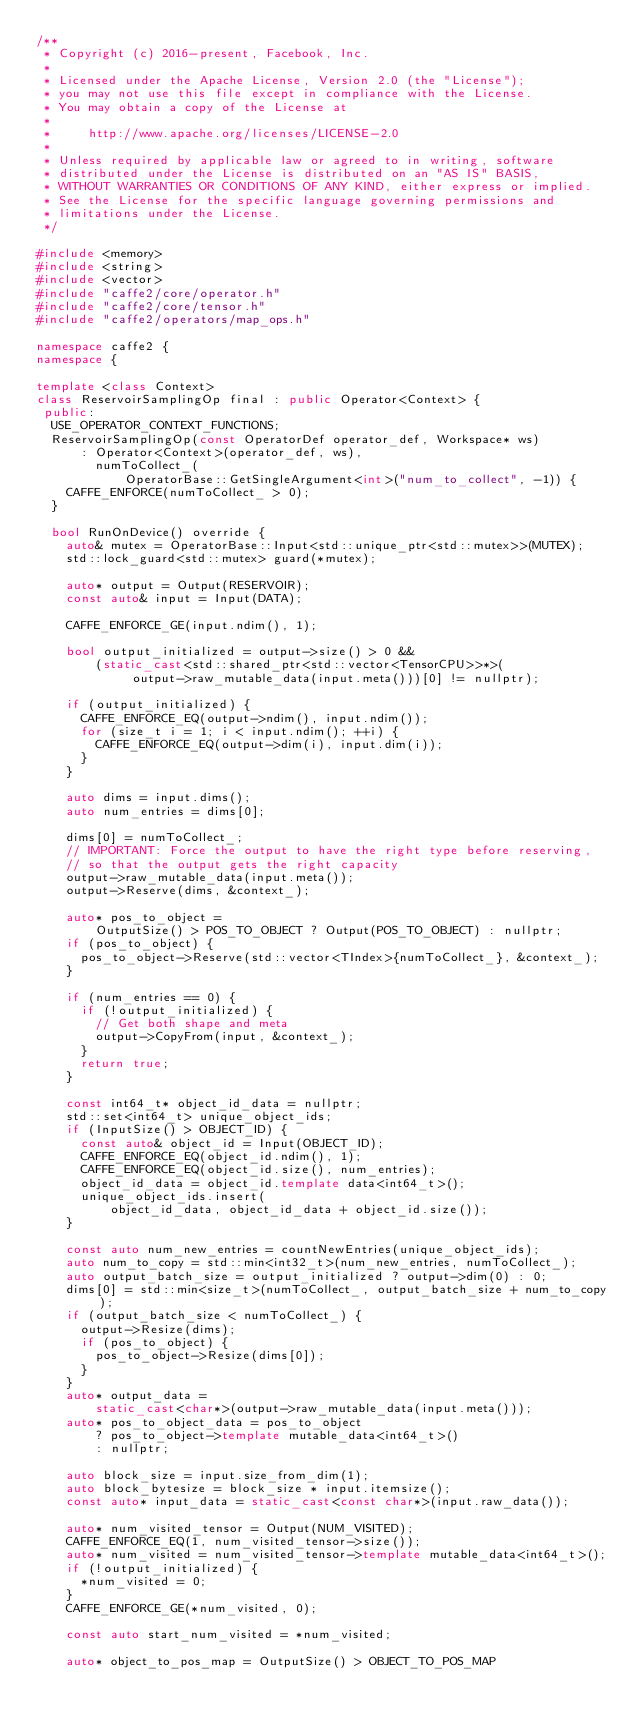<code> <loc_0><loc_0><loc_500><loc_500><_C++_>/**
 * Copyright (c) 2016-present, Facebook, Inc.
 *
 * Licensed under the Apache License, Version 2.0 (the "License");
 * you may not use this file except in compliance with the License.
 * You may obtain a copy of the License at
 *
 *     http://www.apache.org/licenses/LICENSE-2.0
 *
 * Unless required by applicable law or agreed to in writing, software
 * distributed under the License is distributed on an "AS IS" BASIS,
 * WITHOUT WARRANTIES OR CONDITIONS OF ANY KIND, either express or implied.
 * See the License for the specific language governing permissions and
 * limitations under the License.
 */

#include <memory>
#include <string>
#include <vector>
#include "caffe2/core/operator.h"
#include "caffe2/core/tensor.h"
#include "caffe2/operators/map_ops.h"

namespace caffe2 {
namespace {

template <class Context>
class ReservoirSamplingOp final : public Operator<Context> {
 public:
  USE_OPERATOR_CONTEXT_FUNCTIONS;
  ReservoirSamplingOp(const OperatorDef operator_def, Workspace* ws)
      : Operator<Context>(operator_def, ws),
        numToCollect_(
            OperatorBase::GetSingleArgument<int>("num_to_collect", -1)) {
    CAFFE_ENFORCE(numToCollect_ > 0);
  }

  bool RunOnDevice() override {
    auto& mutex = OperatorBase::Input<std::unique_ptr<std::mutex>>(MUTEX);
    std::lock_guard<std::mutex> guard(*mutex);

    auto* output = Output(RESERVOIR);
    const auto& input = Input(DATA);

    CAFFE_ENFORCE_GE(input.ndim(), 1);

    bool output_initialized = output->size() > 0 &&
        (static_cast<std::shared_ptr<std::vector<TensorCPU>>*>(
             output->raw_mutable_data(input.meta()))[0] != nullptr);

    if (output_initialized) {
      CAFFE_ENFORCE_EQ(output->ndim(), input.ndim());
      for (size_t i = 1; i < input.ndim(); ++i) {
        CAFFE_ENFORCE_EQ(output->dim(i), input.dim(i));
      }
    }

    auto dims = input.dims();
    auto num_entries = dims[0];

    dims[0] = numToCollect_;
    // IMPORTANT: Force the output to have the right type before reserving,
    // so that the output gets the right capacity
    output->raw_mutable_data(input.meta());
    output->Reserve(dims, &context_);

    auto* pos_to_object =
        OutputSize() > POS_TO_OBJECT ? Output(POS_TO_OBJECT) : nullptr;
    if (pos_to_object) {
      pos_to_object->Reserve(std::vector<TIndex>{numToCollect_}, &context_);
    }

    if (num_entries == 0) {
      if (!output_initialized) {
        // Get both shape and meta
        output->CopyFrom(input, &context_);
      }
      return true;
    }

    const int64_t* object_id_data = nullptr;
    std::set<int64_t> unique_object_ids;
    if (InputSize() > OBJECT_ID) {
      const auto& object_id = Input(OBJECT_ID);
      CAFFE_ENFORCE_EQ(object_id.ndim(), 1);
      CAFFE_ENFORCE_EQ(object_id.size(), num_entries);
      object_id_data = object_id.template data<int64_t>();
      unique_object_ids.insert(
          object_id_data, object_id_data + object_id.size());
    }

    const auto num_new_entries = countNewEntries(unique_object_ids);
    auto num_to_copy = std::min<int32_t>(num_new_entries, numToCollect_);
    auto output_batch_size = output_initialized ? output->dim(0) : 0;
    dims[0] = std::min<size_t>(numToCollect_, output_batch_size + num_to_copy);
    if (output_batch_size < numToCollect_) {
      output->Resize(dims);
      if (pos_to_object) {
        pos_to_object->Resize(dims[0]);
      }
    }
    auto* output_data =
        static_cast<char*>(output->raw_mutable_data(input.meta()));
    auto* pos_to_object_data = pos_to_object
        ? pos_to_object->template mutable_data<int64_t>()
        : nullptr;

    auto block_size = input.size_from_dim(1);
    auto block_bytesize = block_size * input.itemsize();
    const auto* input_data = static_cast<const char*>(input.raw_data());

    auto* num_visited_tensor = Output(NUM_VISITED);
    CAFFE_ENFORCE_EQ(1, num_visited_tensor->size());
    auto* num_visited = num_visited_tensor->template mutable_data<int64_t>();
    if (!output_initialized) {
      *num_visited = 0;
    }
    CAFFE_ENFORCE_GE(*num_visited, 0);

    const auto start_num_visited = *num_visited;

    auto* object_to_pos_map = OutputSize() > OBJECT_TO_POS_MAP</code> 